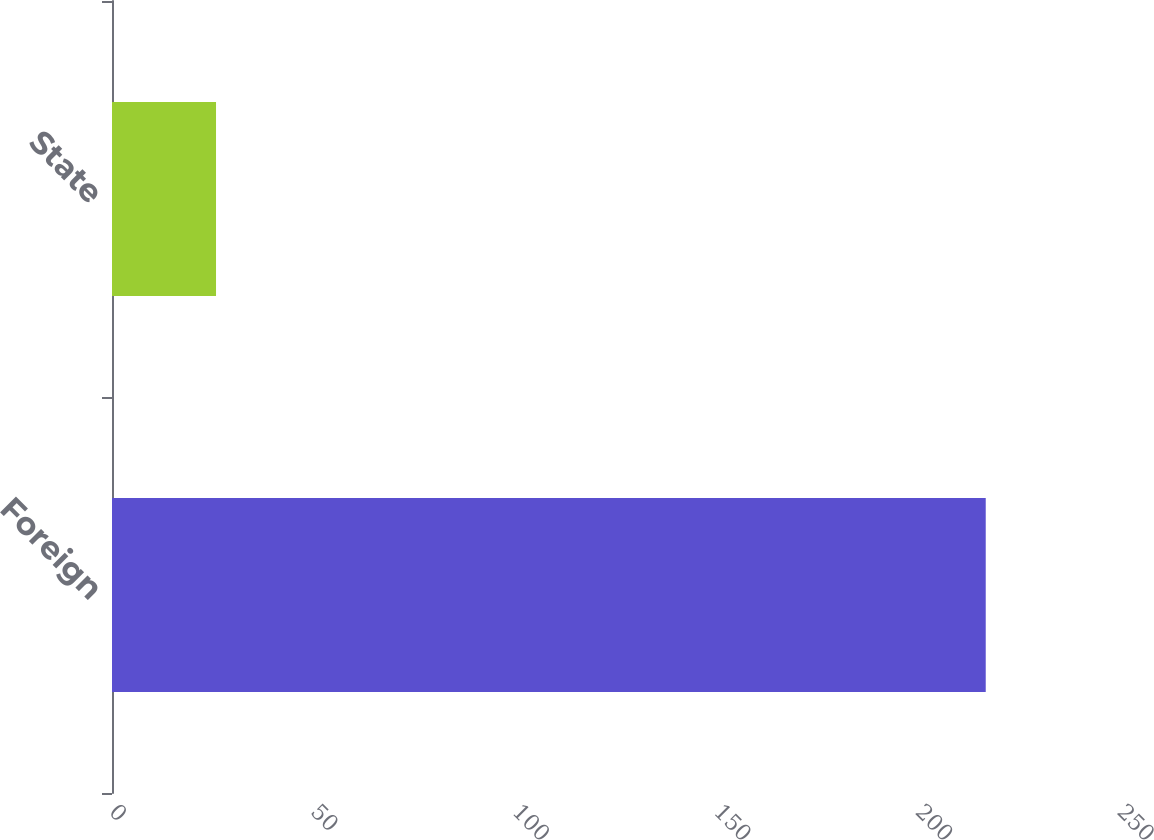Convert chart. <chart><loc_0><loc_0><loc_500><loc_500><bar_chart><fcel>Foreign<fcel>State<nl><fcel>216.7<fcel>25.8<nl></chart> 